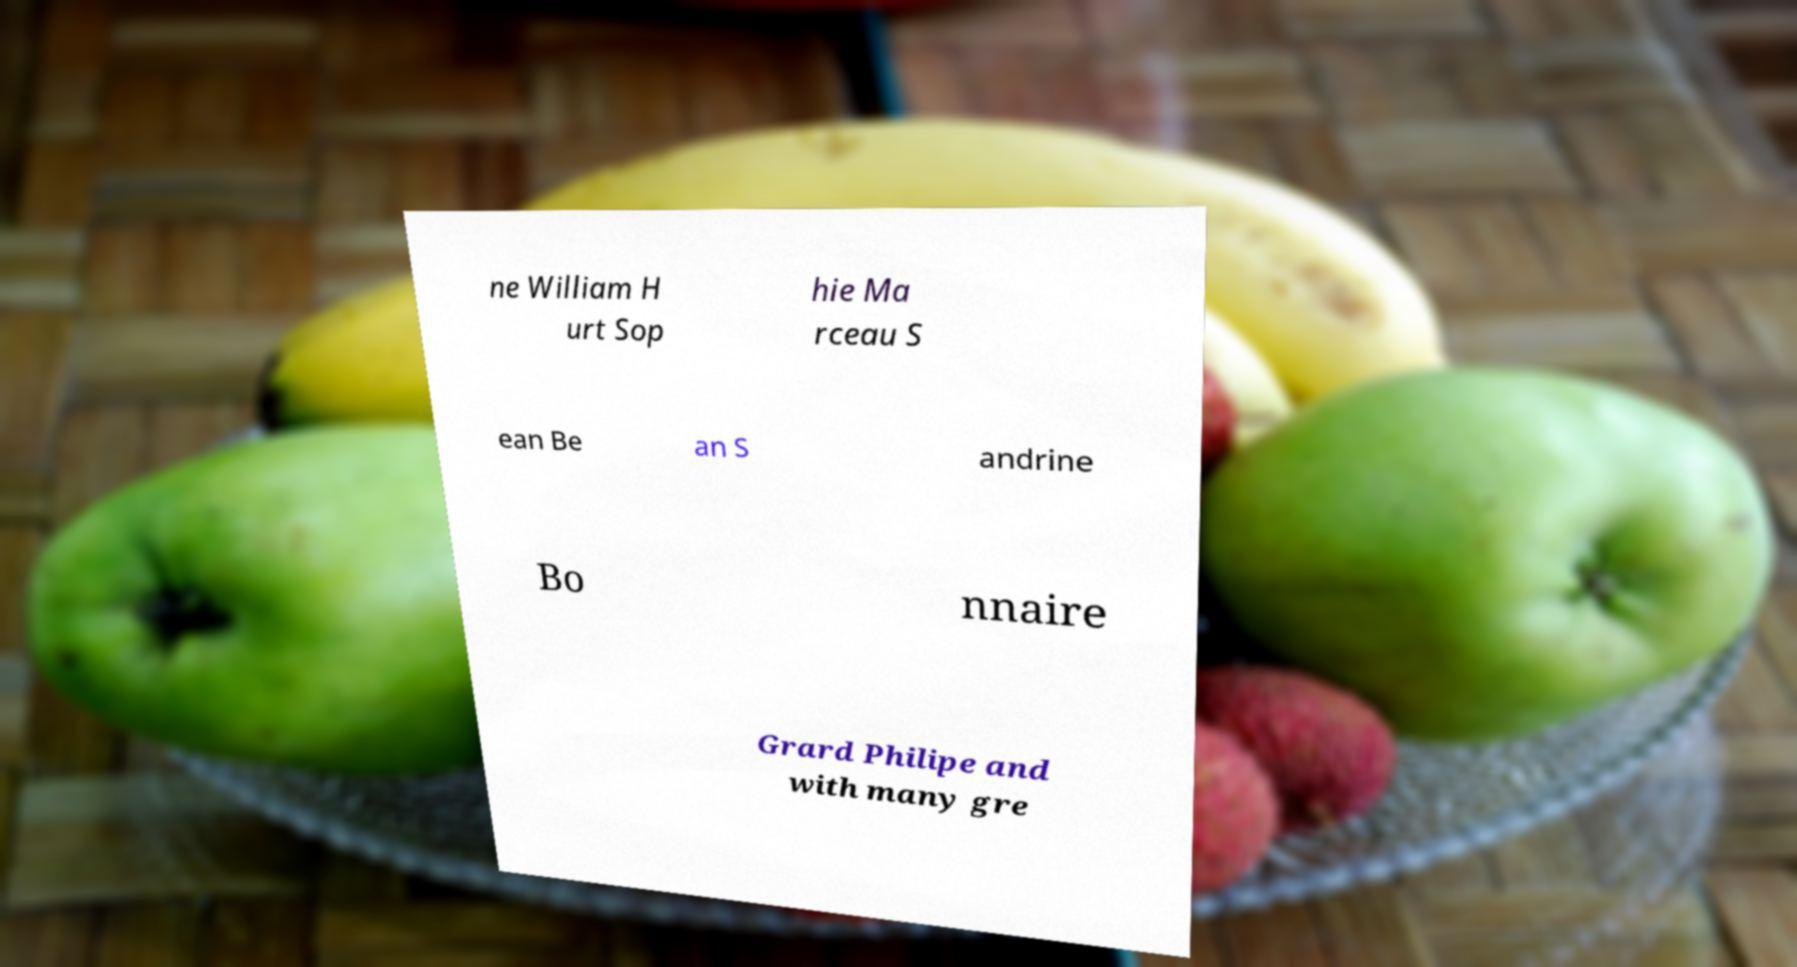There's text embedded in this image that I need extracted. Can you transcribe it verbatim? ne William H urt Sop hie Ma rceau S ean Be an S andrine Bo nnaire Grard Philipe and with many gre 